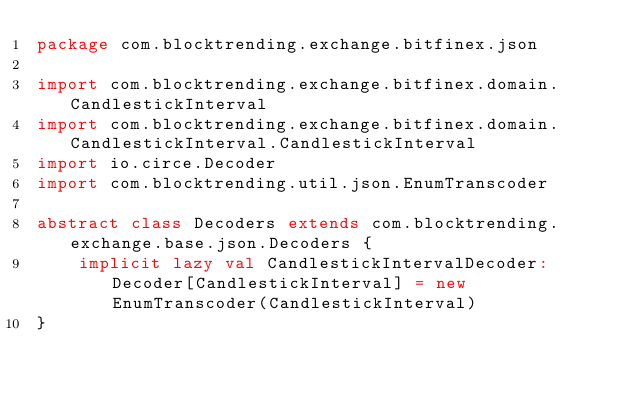Convert code to text. <code><loc_0><loc_0><loc_500><loc_500><_Scala_>package com.blocktrending.exchange.bitfinex.json

import com.blocktrending.exchange.bitfinex.domain.CandlestickInterval
import com.blocktrending.exchange.bitfinex.domain.CandlestickInterval.CandlestickInterval
import io.circe.Decoder
import com.blocktrending.util.json.EnumTranscoder

abstract class Decoders extends com.blocktrending.exchange.base.json.Decoders {
	implicit lazy val CandlestickIntervalDecoder: Decoder[CandlestickInterval] = new EnumTranscoder(CandlestickInterval)
}



</code> 